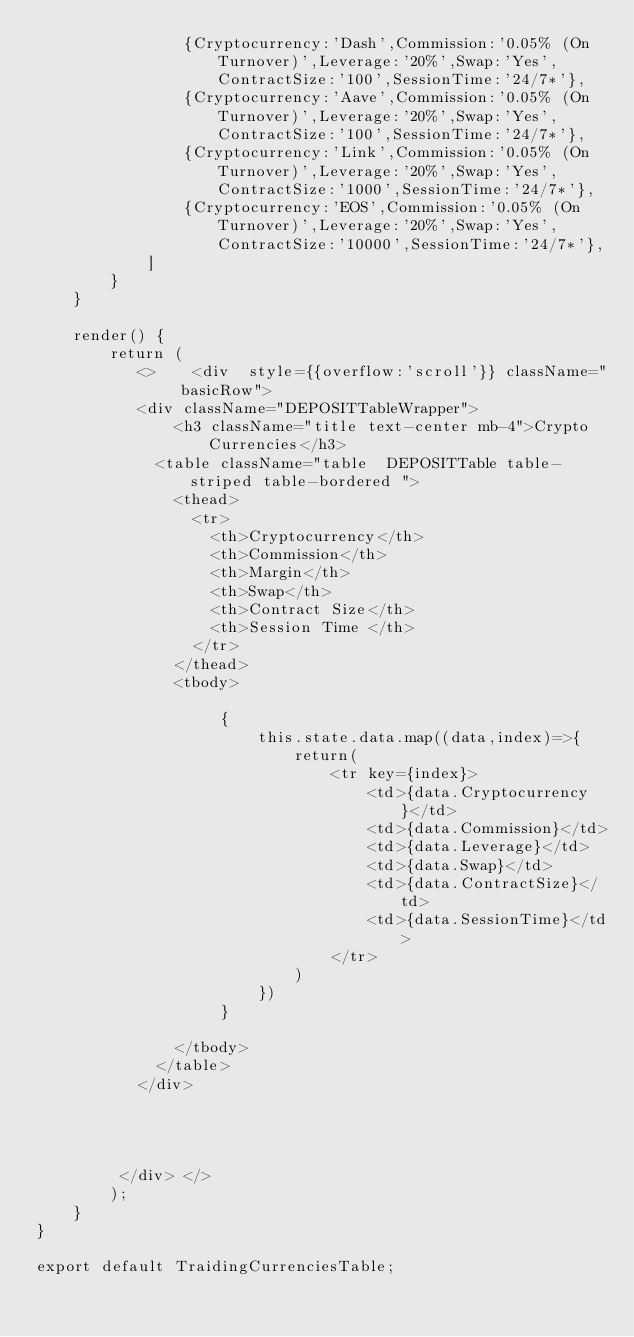<code> <loc_0><loc_0><loc_500><loc_500><_JavaScript_>                {Cryptocurrency:'Dash',Commission:'0.05% (On Turnover)',Leverage:'20%',Swap:'Yes',ContractSize:'100',SessionTime:'24/7*'},
                {Cryptocurrency:'Aave',Commission:'0.05% (On Turnover)',Leverage:'20%',Swap:'Yes',ContractSize:'100',SessionTime:'24/7*'},
                {Cryptocurrency:'Link',Commission:'0.05% (On Turnover)',Leverage:'20%',Swap:'Yes',ContractSize:'1000',SessionTime:'24/7*'},
                {Cryptocurrency:'EOS',Commission:'0.05% (On Turnover)',Leverage:'20%',Swap:'Yes',ContractSize:'10000',SessionTime:'24/7*'},
            ]
        }
    }

    render() {
        return (
           <>    <div  style={{overflow:'scroll'}} className=" basicRow">
           <div className="DEPOSITTableWrapper">
               <h3 className="title text-center mb-4">Crypto Currencies</h3>
             <table className="table  DEPOSITTable table-striped table-bordered ">
               <thead>
                 <tr>
                   <th>Cryptocurrency</th>
                   <th>Commission</th>
                   <th>Margin</th>
                   <th>Swap</th>
                   <th>Contract Size</th>
                   <th>Session Time </th>
                 </tr>
               </thead>
               <tbody>

                    {
                        this.state.data.map((data,index)=>{
                            return(
                                <tr key={index}>
                                    <td>{data.Cryptocurrency}</td>
                                    <td>{data.Commission}</td>
                                    <td>{data.Leverage}</td>
                                    <td>{data.Swap}</td>
                                    <td>{data.ContractSize}</td>
                                    <td>{data.SessionTime}</td>
                                </tr>
                            )
                        })
                    }

               </tbody>
             </table>
           </div>




         </div> </>
        );
    }
}

export default TraidingCurrenciesTable;
</code> 